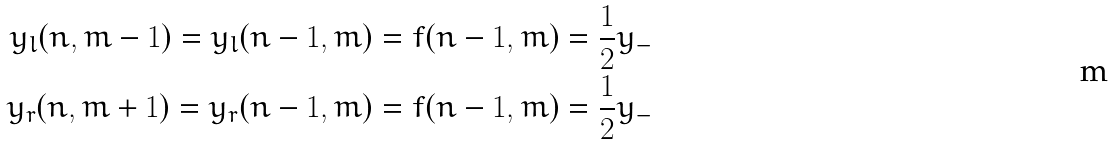Convert formula to latex. <formula><loc_0><loc_0><loc_500><loc_500>y _ { l } ( n , m - 1 ) = y _ { l } ( n - 1 , m ) = f ( n - 1 , m ) = \frac { 1 } { 2 } y _ { - } \\ y _ { r } ( n , m + 1 ) = y _ { r } ( n - 1 , m ) = f ( n - 1 , m ) = \frac { 1 } { 2 } y _ { - }</formula> 